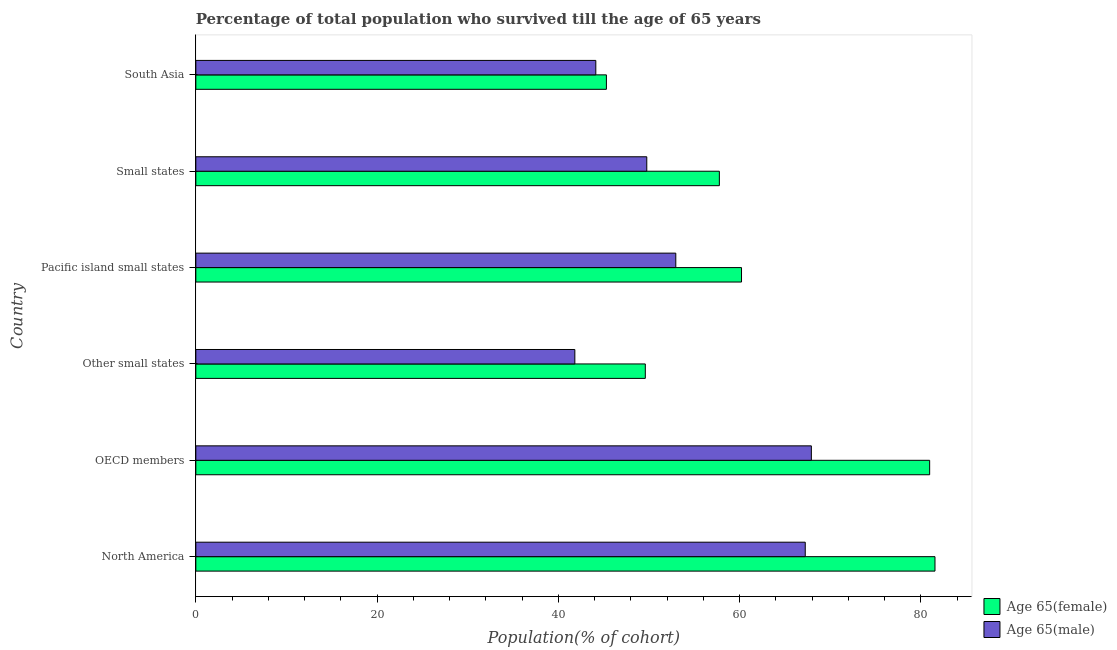Are the number of bars per tick equal to the number of legend labels?
Your response must be concise. Yes. How many bars are there on the 4th tick from the bottom?
Offer a terse response. 2. What is the label of the 5th group of bars from the top?
Provide a short and direct response. OECD members. What is the percentage of male population who survived till age of 65 in South Asia?
Offer a terse response. 44.13. Across all countries, what is the maximum percentage of male population who survived till age of 65?
Provide a short and direct response. 67.91. Across all countries, what is the minimum percentage of female population who survived till age of 65?
Ensure brevity in your answer.  45.3. In which country was the percentage of female population who survived till age of 65 maximum?
Provide a succinct answer. North America. In which country was the percentage of male population who survived till age of 65 minimum?
Offer a very short reply. Other small states. What is the total percentage of female population who survived till age of 65 in the graph?
Offer a very short reply. 375.36. What is the difference between the percentage of female population who survived till age of 65 in Other small states and that in Pacific island small states?
Ensure brevity in your answer.  -10.61. What is the difference between the percentage of male population who survived till age of 65 in OECD members and the percentage of female population who survived till age of 65 in Other small states?
Provide a succinct answer. 18.32. What is the average percentage of female population who survived till age of 65 per country?
Offer a terse response. 62.56. What is the difference between the percentage of male population who survived till age of 65 and percentage of female population who survived till age of 65 in OECD members?
Offer a terse response. -13.05. What is the ratio of the percentage of female population who survived till age of 65 in Small states to that in South Asia?
Ensure brevity in your answer.  1.27. Is the percentage of female population who survived till age of 65 in Small states less than that in South Asia?
Keep it short and to the point. No. What is the difference between the highest and the second highest percentage of female population who survived till age of 65?
Offer a very short reply. 0.59. What is the difference between the highest and the lowest percentage of female population who survived till age of 65?
Your answer should be compact. 36.25. Is the sum of the percentage of female population who survived till age of 65 in North America and South Asia greater than the maximum percentage of male population who survived till age of 65 across all countries?
Offer a terse response. Yes. What does the 1st bar from the top in Small states represents?
Give a very brief answer. Age 65(male). What does the 1st bar from the bottom in Other small states represents?
Offer a very short reply. Age 65(female). What is the difference between two consecutive major ticks on the X-axis?
Your response must be concise. 20. Are the values on the major ticks of X-axis written in scientific E-notation?
Your answer should be very brief. No. Does the graph contain any zero values?
Offer a terse response. No. How many legend labels are there?
Ensure brevity in your answer.  2. What is the title of the graph?
Your response must be concise. Percentage of total population who survived till the age of 65 years. What is the label or title of the X-axis?
Provide a short and direct response. Population(% of cohort). What is the Population(% of cohort) of Age 65(female) in North America?
Offer a very short reply. 81.55. What is the Population(% of cohort) in Age 65(male) in North America?
Ensure brevity in your answer.  67.23. What is the Population(% of cohort) in Age 65(female) in OECD members?
Make the answer very short. 80.96. What is the Population(% of cohort) of Age 65(male) in OECD members?
Your response must be concise. 67.91. What is the Population(% of cohort) in Age 65(female) in Other small states?
Your response must be concise. 49.59. What is the Population(% of cohort) of Age 65(male) in Other small states?
Ensure brevity in your answer.  41.82. What is the Population(% of cohort) in Age 65(female) in Pacific island small states?
Offer a very short reply. 60.2. What is the Population(% of cohort) of Age 65(male) in Pacific island small states?
Keep it short and to the point. 52.95. What is the Population(% of cohort) in Age 65(female) in Small states?
Offer a very short reply. 57.76. What is the Population(% of cohort) in Age 65(male) in Small states?
Ensure brevity in your answer.  49.75. What is the Population(% of cohort) of Age 65(female) in South Asia?
Make the answer very short. 45.3. What is the Population(% of cohort) of Age 65(male) in South Asia?
Your answer should be very brief. 44.13. Across all countries, what is the maximum Population(% of cohort) of Age 65(female)?
Offer a terse response. 81.55. Across all countries, what is the maximum Population(% of cohort) in Age 65(male)?
Your answer should be very brief. 67.91. Across all countries, what is the minimum Population(% of cohort) in Age 65(female)?
Offer a very short reply. 45.3. Across all countries, what is the minimum Population(% of cohort) of Age 65(male)?
Offer a very short reply. 41.82. What is the total Population(% of cohort) in Age 65(female) in the graph?
Give a very brief answer. 375.36. What is the total Population(% of cohort) of Age 65(male) in the graph?
Ensure brevity in your answer.  323.79. What is the difference between the Population(% of cohort) of Age 65(female) in North America and that in OECD members?
Offer a terse response. 0.59. What is the difference between the Population(% of cohort) of Age 65(male) in North America and that in OECD members?
Your answer should be compact. -0.67. What is the difference between the Population(% of cohort) in Age 65(female) in North America and that in Other small states?
Offer a terse response. 31.96. What is the difference between the Population(% of cohort) in Age 65(male) in North America and that in Other small states?
Your answer should be very brief. 25.42. What is the difference between the Population(% of cohort) of Age 65(female) in North America and that in Pacific island small states?
Make the answer very short. 21.34. What is the difference between the Population(% of cohort) of Age 65(male) in North America and that in Pacific island small states?
Provide a succinct answer. 14.28. What is the difference between the Population(% of cohort) in Age 65(female) in North America and that in Small states?
Your answer should be very brief. 23.79. What is the difference between the Population(% of cohort) in Age 65(male) in North America and that in Small states?
Give a very brief answer. 17.48. What is the difference between the Population(% of cohort) of Age 65(female) in North America and that in South Asia?
Provide a short and direct response. 36.25. What is the difference between the Population(% of cohort) of Age 65(male) in North America and that in South Asia?
Provide a short and direct response. 23.11. What is the difference between the Population(% of cohort) in Age 65(female) in OECD members and that in Other small states?
Offer a very short reply. 31.37. What is the difference between the Population(% of cohort) in Age 65(male) in OECD members and that in Other small states?
Offer a very short reply. 26.09. What is the difference between the Population(% of cohort) in Age 65(female) in OECD members and that in Pacific island small states?
Ensure brevity in your answer.  20.76. What is the difference between the Population(% of cohort) of Age 65(male) in OECD members and that in Pacific island small states?
Ensure brevity in your answer.  14.96. What is the difference between the Population(% of cohort) of Age 65(female) in OECD members and that in Small states?
Your response must be concise. 23.2. What is the difference between the Population(% of cohort) of Age 65(male) in OECD members and that in Small states?
Offer a very short reply. 18.16. What is the difference between the Population(% of cohort) in Age 65(female) in OECD members and that in South Asia?
Ensure brevity in your answer.  35.66. What is the difference between the Population(% of cohort) in Age 65(male) in OECD members and that in South Asia?
Make the answer very short. 23.78. What is the difference between the Population(% of cohort) in Age 65(female) in Other small states and that in Pacific island small states?
Your response must be concise. -10.61. What is the difference between the Population(% of cohort) of Age 65(male) in Other small states and that in Pacific island small states?
Your answer should be very brief. -11.14. What is the difference between the Population(% of cohort) of Age 65(female) in Other small states and that in Small states?
Keep it short and to the point. -8.17. What is the difference between the Population(% of cohort) in Age 65(male) in Other small states and that in Small states?
Keep it short and to the point. -7.94. What is the difference between the Population(% of cohort) of Age 65(female) in Other small states and that in South Asia?
Provide a succinct answer. 4.29. What is the difference between the Population(% of cohort) of Age 65(male) in Other small states and that in South Asia?
Provide a short and direct response. -2.31. What is the difference between the Population(% of cohort) in Age 65(female) in Pacific island small states and that in Small states?
Give a very brief answer. 2.44. What is the difference between the Population(% of cohort) of Age 65(male) in Pacific island small states and that in Small states?
Keep it short and to the point. 3.2. What is the difference between the Population(% of cohort) in Age 65(female) in Pacific island small states and that in South Asia?
Keep it short and to the point. 14.91. What is the difference between the Population(% of cohort) in Age 65(male) in Pacific island small states and that in South Asia?
Give a very brief answer. 8.82. What is the difference between the Population(% of cohort) in Age 65(female) in Small states and that in South Asia?
Your answer should be compact. 12.46. What is the difference between the Population(% of cohort) in Age 65(male) in Small states and that in South Asia?
Offer a terse response. 5.62. What is the difference between the Population(% of cohort) in Age 65(female) in North America and the Population(% of cohort) in Age 65(male) in OECD members?
Provide a succinct answer. 13.64. What is the difference between the Population(% of cohort) of Age 65(female) in North America and the Population(% of cohort) of Age 65(male) in Other small states?
Your answer should be compact. 39.73. What is the difference between the Population(% of cohort) in Age 65(female) in North America and the Population(% of cohort) in Age 65(male) in Pacific island small states?
Keep it short and to the point. 28.6. What is the difference between the Population(% of cohort) of Age 65(female) in North America and the Population(% of cohort) of Age 65(male) in Small states?
Your response must be concise. 31.8. What is the difference between the Population(% of cohort) of Age 65(female) in North America and the Population(% of cohort) of Age 65(male) in South Asia?
Provide a succinct answer. 37.42. What is the difference between the Population(% of cohort) of Age 65(female) in OECD members and the Population(% of cohort) of Age 65(male) in Other small states?
Your answer should be very brief. 39.14. What is the difference between the Population(% of cohort) of Age 65(female) in OECD members and the Population(% of cohort) of Age 65(male) in Pacific island small states?
Your response must be concise. 28.01. What is the difference between the Population(% of cohort) in Age 65(female) in OECD members and the Population(% of cohort) in Age 65(male) in Small states?
Your response must be concise. 31.21. What is the difference between the Population(% of cohort) in Age 65(female) in OECD members and the Population(% of cohort) in Age 65(male) in South Asia?
Ensure brevity in your answer.  36.83. What is the difference between the Population(% of cohort) of Age 65(female) in Other small states and the Population(% of cohort) of Age 65(male) in Pacific island small states?
Provide a short and direct response. -3.36. What is the difference between the Population(% of cohort) in Age 65(female) in Other small states and the Population(% of cohort) in Age 65(male) in Small states?
Offer a very short reply. -0.16. What is the difference between the Population(% of cohort) in Age 65(female) in Other small states and the Population(% of cohort) in Age 65(male) in South Asia?
Your answer should be very brief. 5.46. What is the difference between the Population(% of cohort) in Age 65(female) in Pacific island small states and the Population(% of cohort) in Age 65(male) in Small states?
Your answer should be very brief. 10.45. What is the difference between the Population(% of cohort) in Age 65(female) in Pacific island small states and the Population(% of cohort) in Age 65(male) in South Asia?
Your response must be concise. 16.08. What is the difference between the Population(% of cohort) in Age 65(female) in Small states and the Population(% of cohort) in Age 65(male) in South Asia?
Your response must be concise. 13.63. What is the average Population(% of cohort) of Age 65(female) per country?
Provide a short and direct response. 62.56. What is the average Population(% of cohort) of Age 65(male) per country?
Make the answer very short. 53.96. What is the difference between the Population(% of cohort) in Age 65(female) and Population(% of cohort) in Age 65(male) in North America?
Make the answer very short. 14.31. What is the difference between the Population(% of cohort) in Age 65(female) and Population(% of cohort) in Age 65(male) in OECD members?
Your answer should be compact. 13.05. What is the difference between the Population(% of cohort) of Age 65(female) and Population(% of cohort) of Age 65(male) in Other small states?
Provide a short and direct response. 7.77. What is the difference between the Population(% of cohort) in Age 65(female) and Population(% of cohort) in Age 65(male) in Pacific island small states?
Provide a succinct answer. 7.25. What is the difference between the Population(% of cohort) in Age 65(female) and Population(% of cohort) in Age 65(male) in Small states?
Give a very brief answer. 8.01. What is the difference between the Population(% of cohort) in Age 65(female) and Population(% of cohort) in Age 65(male) in South Asia?
Provide a succinct answer. 1.17. What is the ratio of the Population(% of cohort) in Age 65(female) in North America to that in OECD members?
Your answer should be very brief. 1.01. What is the ratio of the Population(% of cohort) of Age 65(male) in North America to that in OECD members?
Your response must be concise. 0.99. What is the ratio of the Population(% of cohort) in Age 65(female) in North America to that in Other small states?
Give a very brief answer. 1.64. What is the ratio of the Population(% of cohort) of Age 65(male) in North America to that in Other small states?
Your answer should be compact. 1.61. What is the ratio of the Population(% of cohort) in Age 65(female) in North America to that in Pacific island small states?
Offer a very short reply. 1.35. What is the ratio of the Population(% of cohort) of Age 65(male) in North America to that in Pacific island small states?
Give a very brief answer. 1.27. What is the ratio of the Population(% of cohort) of Age 65(female) in North America to that in Small states?
Your response must be concise. 1.41. What is the ratio of the Population(% of cohort) in Age 65(male) in North America to that in Small states?
Provide a succinct answer. 1.35. What is the ratio of the Population(% of cohort) in Age 65(female) in North America to that in South Asia?
Keep it short and to the point. 1.8. What is the ratio of the Population(% of cohort) in Age 65(male) in North America to that in South Asia?
Give a very brief answer. 1.52. What is the ratio of the Population(% of cohort) of Age 65(female) in OECD members to that in Other small states?
Provide a succinct answer. 1.63. What is the ratio of the Population(% of cohort) of Age 65(male) in OECD members to that in Other small states?
Offer a terse response. 1.62. What is the ratio of the Population(% of cohort) of Age 65(female) in OECD members to that in Pacific island small states?
Give a very brief answer. 1.34. What is the ratio of the Population(% of cohort) in Age 65(male) in OECD members to that in Pacific island small states?
Provide a succinct answer. 1.28. What is the ratio of the Population(% of cohort) in Age 65(female) in OECD members to that in Small states?
Ensure brevity in your answer.  1.4. What is the ratio of the Population(% of cohort) of Age 65(male) in OECD members to that in Small states?
Your answer should be very brief. 1.36. What is the ratio of the Population(% of cohort) in Age 65(female) in OECD members to that in South Asia?
Your response must be concise. 1.79. What is the ratio of the Population(% of cohort) in Age 65(male) in OECD members to that in South Asia?
Offer a very short reply. 1.54. What is the ratio of the Population(% of cohort) in Age 65(female) in Other small states to that in Pacific island small states?
Offer a very short reply. 0.82. What is the ratio of the Population(% of cohort) in Age 65(male) in Other small states to that in Pacific island small states?
Provide a short and direct response. 0.79. What is the ratio of the Population(% of cohort) in Age 65(female) in Other small states to that in Small states?
Offer a terse response. 0.86. What is the ratio of the Population(% of cohort) in Age 65(male) in Other small states to that in Small states?
Your answer should be very brief. 0.84. What is the ratio of the Population(% of cohort) in Age 65(female) in Other small states to that in South Asia?
Your response must be concise. 1.09. What is the ratio of the Population(% of cohort) of Age 65(male) in Other small states to that in South Asia?
Give a very brief answer. 0.95. What is the ratio of the Population(% of cohort) of Age 65(female) in Pacific island small states to that in Small states?
Offer a terse response. 1.04. What is the ratio of the Population(% of cohort) in Age 65(male) in Pacific island small states to that in Small states?
Keep it short and to the point. 1.06. What is the ratio of the Population(% of cohort) in Age 65(female) in Pacific island small states to that in South Asia?
Your response must be concise. 1.33. What is the ratio of the Population(% of cohort) in Age 65(male) in Pacific island small states to that in South Asia?
Your response must be concise. 1.2. What is the ratio of the Population(% of cohort) in Age 65(female) in Small states to that in South Asia?
Keep it short and to the point. 1.28. What is the ratio of the Population(% of cohort) of Age 65(male) in Small states to that in South Asia?
Your response must be concise. 1.13. What is the difference between the highest and the second highest Population(% of cohort) of Age 65(female)?
Your answer should be compact. 0.59. What is the difference between the highest and the second highest Population(% of cohort) of Age 65(male)?
Your response must be concise. 0.67. What is the difference between the highest and the lowest Population(% of cohort) of Age 65(female)?
Your answer should be very brief. 36.25. What is the difference between the highest and the lowest Population(% of cohort) in Age 65(male)?
Ensure brevity in your answer.  26.09. 